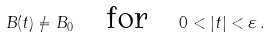<formula> <loc_0><loc_0><loc_500><loc_500>B ( t ) \neq B _ { 0 } \quad \text {for} \quad 0 < | t | < \varepsilon \, .</formula> 